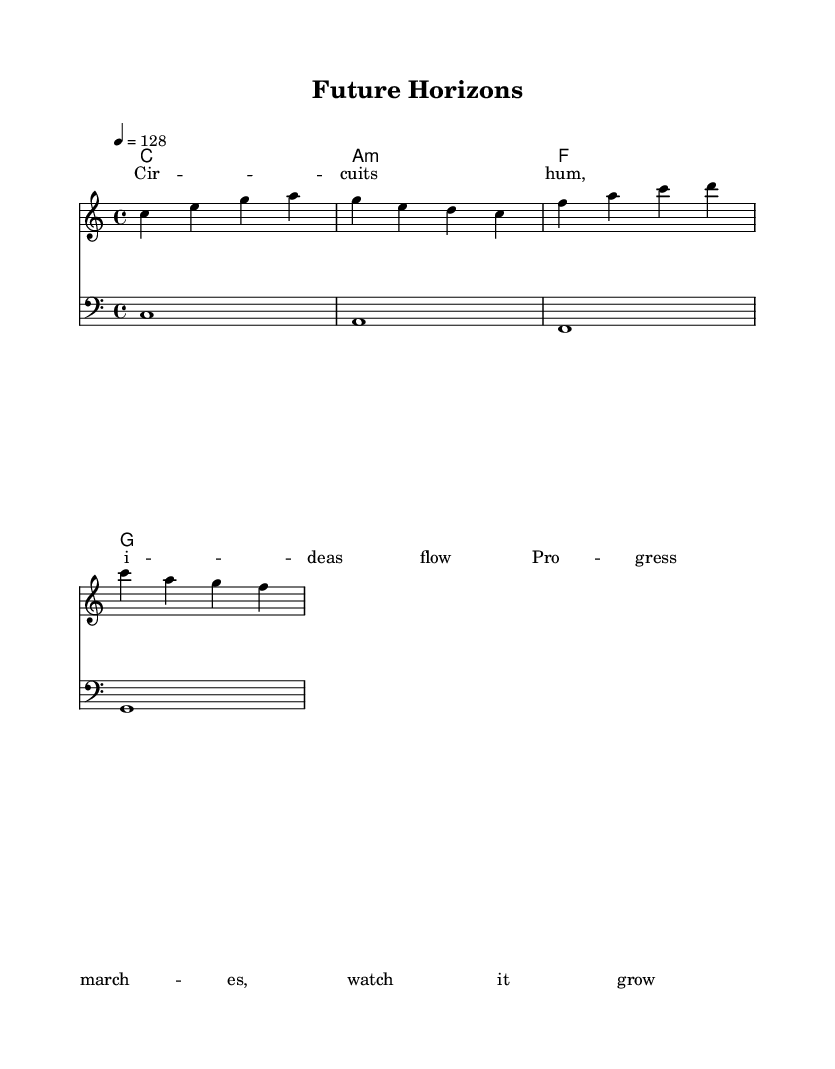What is the key signature of this music? The key signature displayed in the sheet music indicates it is in C major, which has no sharps or flats.
Answer: C major What is the time signature of this piece? The time signature shown is 4/4, which means there are four beats per measure and each quarter note gets one beat.
Answer: 4/4 What is the tempo marking for this piece? The tempo marking in the score indicates a speed of 128 beats per minute, meaning the piece is to be played in a moderately fast tempo.
Answer: 128 How many measures are there in the melody? By counting the distinct measures indicated in the melody section of the score, there are four measures in total.
Answer: 4 What are the primary chords used in the harmonies? The harmonies indicate the primary chords of C major, A minor, F major, and G major, which are all foundational chords in this key.
Answer: C, A minor, F, G What lyrical theme can be inferred from the text? The lyrics mention "Circuits hum, ideas flow" and "Progress marches, watch it grow," suggesting an upbeat theme related to technological innovation and advancement.
Answer: Technological innovation Which clef is used for the bass line? The bass line in the score is written in the bass clef, which is typically used for lower-pitched instruments and voices.
Answer: Bass clef 